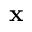<formula> <loc_0><loc_0><loc_500><loc_500>x</formula> 